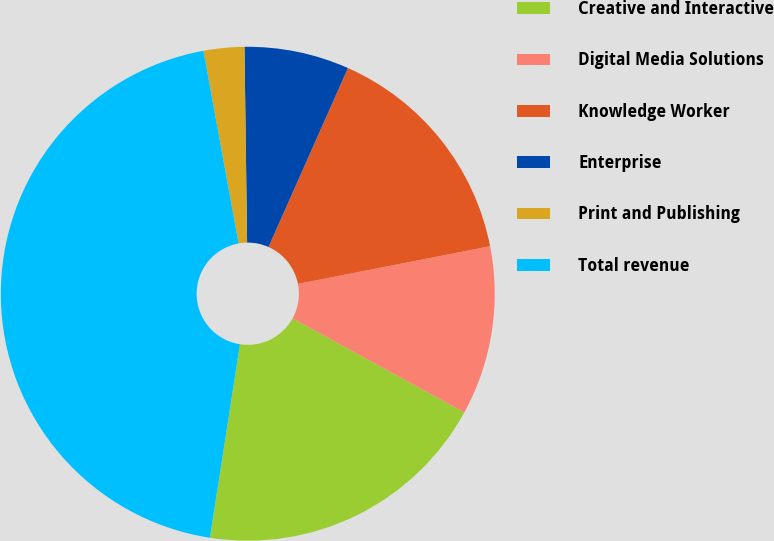Convert chart to OTSL. <chart><loc_0><loc_0><loc_500><loc_500><pie_chart><fcel>Creative and Interactive<fcel>Digital Media Solutions<fcel>Knowledge Worker<fcel>Enterprise<fcel>Print and Publishing<fcel>Total revenue<nl><fcel>19.47%<fcel>11.06%<fcel>15.27%<fcel>6.86%<fcel>2.66%<fcel>44.68%<nl></chart> 